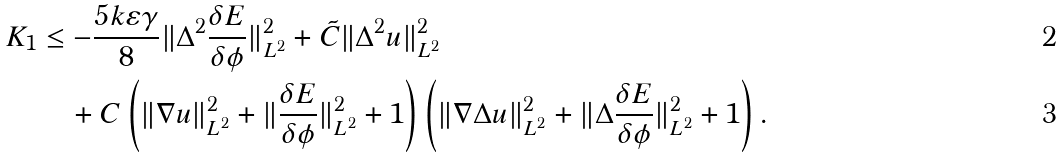Convert formula to latex. <formula><loc_0><loc_0><loc_500><loc_500>K _ { 1 } & \leq - \frac { 5 k \varepsilon \gamma } { 8 } \| \Delta ^ { 2 } \frac { \delta E } { \delta \phi } \| _ { L ^ { 2 } } ^ { 2 } + \tilde { C } \| \Delta ^ { 2 } u \| _ { L ^ { 2 } } ^ { 2 } \\ & \quad + C \left ( \| \nabla u \| _ { L ^ { 2 } } ^ { 2 } + \| \frac { \delta E } { \delta \phi } \| _ { L ^ { 2 } } ^ { 2 } + 1 \right ) \left ( \| \nabla \Delta u \| _ { L ^ { 2 } } ^ { 2 } + \| \Delta \frac { \delta E } { \delta \phi } \| _ { L ^ { 2 } } ^ { 2 } + 1 \right ) .</formula> 